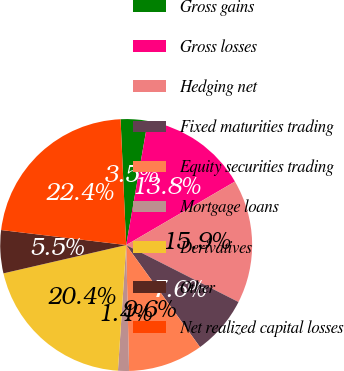<chart> <loc_0><loc_0><loc_500><loc_500><pie_chart><fcel>Gross gains<fcel>Gross losses<fcel>Hedging net<fcel>Fixed maturities trading<fcel>Equity securities trading<fcel>Mortgage loans<fcel>Derivatives<fcel>Other<fcel>Net realized capital losses<nl><fcel>3.46%<fcel>13.84%<fcel>15.88%<fcel>7.56%<fcel>9.6%<fcel>1.41%<fcel>20.35%<fcel>5.51%<fcel>22.39%<nl></chart> 